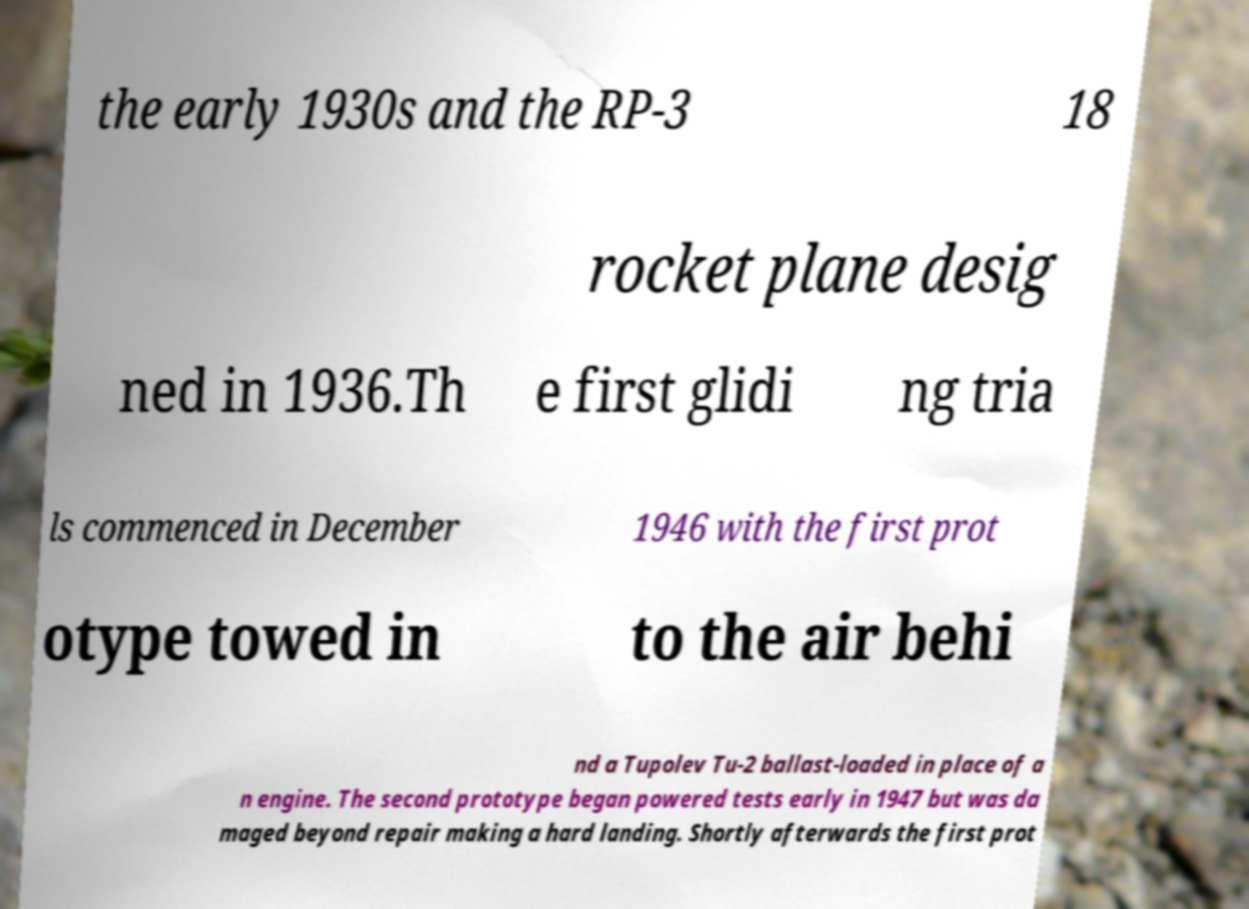I need the written content from this picture converted into text. Can you do that? the early 1930s and the RP-3 18 rocket plane desig ned in 1936.Th e first glidi ng tria ls commenced in December 1946 with the first prot otype towed in to the air behi nd a Tupolev Tu-2 ballast-loaded in place of a n engine. The second prototype began powered tests early in 1947 but was da maged beyond repair making a hard landing. Shortly afterwards the first prot 